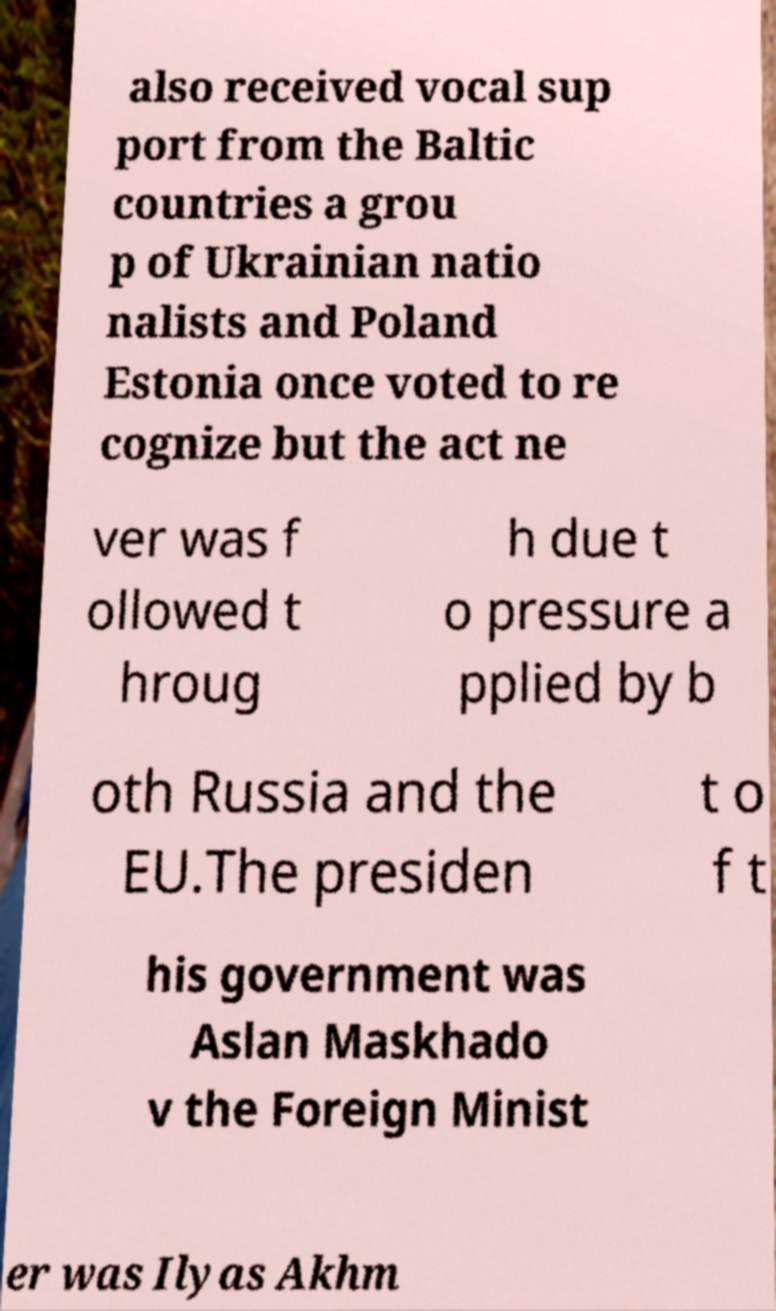I need the written content from this picture converted into text. Can you do that? also received vocal sup port from the Baltic countries a grou p of Ukrainian natio nalists and Poland Estonia once voted to re cognize but the act ne ver was f ollowed t hroug h due t o pressure a pplied by b oth Russia and the EU.The presiden t o f t his government was Aslan Maskhado v the Foreign Minist er was Ilyas Akhm 